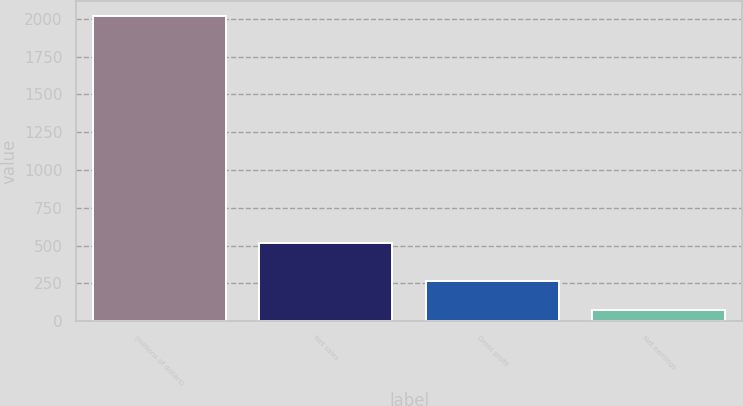<chart> <loc_0><loc_0><loc_500><loc_500><bar_chart><fcel>(millions of dollars)<fcel>Net sales<fcel>Gross profit<fcel>Net earnings<nl><fcel>2015<fcel>519<fcel>267.47<fcel>73.3<nl></chart> 